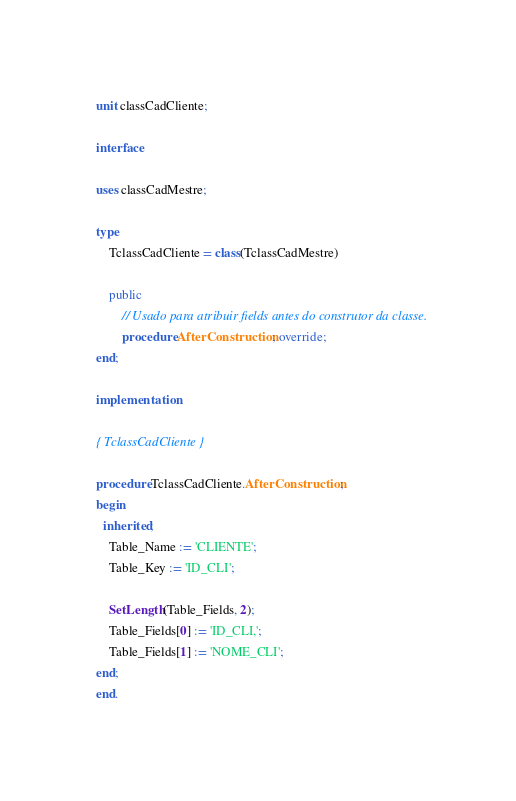Convert code to text. <code><loc_0><loc_0><loc_500><loc_500><_Pascal_>unit classCadCliente;

interface

uses classCadMestre;

type
    TclassCadCliente = class(TclassCadMestre)

    public
        // Usado para atribuir fields antes do construtor da classe.
        procedure AfterConstruction; override;
end;

implementation

{ TclassCadCliente }

procedure TclassCadCliente.AfterConstruction;
begin
  inherited;
    Table_Name := 'CLIENTE';
    Table_Key := 'ID_CLI';

    SetLength(Table_Fields, 2);
    Table_Fields[0] := 'ID_CLI,';
    Table_Fields[1] := 'NOME_CLI';
end;
end.

</code> 